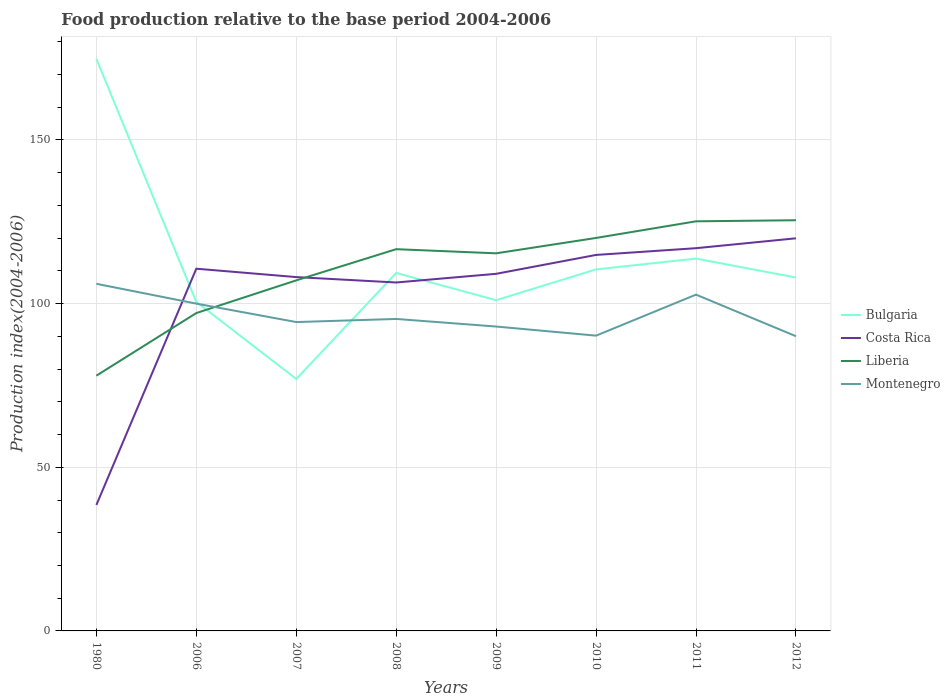Does the line corresponding to Montenegro intersect with the line corresponding to Liberia?
Make the answer very short. Yes. Is the number of lines equal to the number of legend labels?
Your answer should be very brief. Yes. Across all years, what is the maximum food production index in Costa Rica?
Offer a very short reply. 38.48. What is the total food production index in Costa Rica in the graph?
Offer a very short reply. -6.27. What is the difference between the highest and the second highest food production index in Montenegro?
Offer a very short reply. 16.02. How many lines are there?
Your answer should be compact. 4. How many years are there in the graph?
Your response must be concise. 8. How many legend labels are there?
Your response must be concise. 4. What is the title of the graph?
Your answer should be very brief. Food production relative to the base period 2004-2006. Does "Morocco" appear as one of the legend labels in the graph?
Give a very brief answer. No. What is the label or title of the Y-axis?
Provide a succinct answer. Production index(2004-2006). What is the Production index(2004-2006) in Bulgaria in 1980?
Make the answer very short. 174.78. What is the Production index(2004-2006) of Costa Rica in 1980?
Offer a very short reply. 38.48. What is the Production index(2004-2006) in Liberia in 1980?
Your answer should be very brief. 77.99. What is the Production index(2004-2006) of Montenegro in 1980?
Offer a terse response. 106.06. What is the Production index(2004-2006) of Bulgaria in 2006?
Your answer should be very brief. 100.53. What is the Production index(2004-2006) of Costa Rica in 2006?
Give a very brief answer. 110.67. What is the Production index(2004-2006) of Liberia in 2006?
Your response must be concise. 97.12. What is the Production index(2004-2006) of Bulgaria in 2007?
Provide a short and direct response. 76.98. What is the Production index(2004-2006) of Costa Rica in 2007?
Provide a succinct answer. 108.11. What is the Production index(2004-2006) in Liberia in 2007?
Provide a succinct answer. 107.11. What is the Production index(2004-2006) in Montenegro in 2007?
Offer a terse response. 94.37. What is the Production index(2004-2006) of Bulgaria in 2008?
Your response must be concise. 109.37. What is the Production index(2004-2006) in Costa Rica in 2008?
Make the answer very short. 106.46. What is the Production index(2004-2006) in Liberia in 2008?
Your answer should be compact. 116.64. What is the Production index(2004-2006) in Montenegro in 2008?
Provide a succinct answer. 95.32. What is the Production index(2004-2006) in Bulgaria in 2009?
Ensure brevity in your answer.  101.05. What is the Production index(2004-2006) in Costa Rica in 2009?
Make the answer very short. 109.11. What is the Production index(2004-2006) in Liberia in 2009?
Your answer should be very brief. 115.37. What is the Production index(2004-2006) in Montenegro in 2009?
Give a very brief answer. 93. What is the Production index(2004-2006) of Bulgaria in 2010?
Ensure brevity in your answer.  110.47. What is the Production index(2004-2006) in Costa Rica in 2010?
Make the answer very short. 114.88. What is the Production index(2004-2006) of Liberia in 2010?
Make the answer very short. 120.07. What is the Production index(2004-2006) in Montenegro in 2010?
Ensure brevity in your answer.  90.22. What is the Production index(2004-2006) in Bulgaria in 2011?
Ensure brevity in your answer.  113.76. What is the Production index(2004-2006) in Costa Rica in 2011?
Ensure brevity in your answer.  116.94. What is the Production index(2004-2006) of Liberia in 2011?
Your response must be concise. 125.15. What is the Production index(2004-2006) in Montenegro in 2011?
Keep it short and to the point. 102.75. What is the Production index(2004-2006) of Bulgaria in 2012?
Your answer should be compact. 107.98. What is the Production index(2004-2006) of Costa Rica in 2012?
Keep it short and to the point. 119.96. What is the Production index(2004-2006) of Liberia in 2012?
Your answer should be compact. 125.48. What is the Production index(2004-2006) in Montenegro in 2012?
Keep it short and to the point. 90.04. Across all years, what is the maximum Production index(2004-2006) of Bulgaria?
Give a very brief answer. 174.78. Across all years, what is the maximum Production index(2004-2006) of Costa Rica?
Ensure brevity in your answer.  119.96. Across all years, what is the maximum Production index(2004-2006) in Liberia?
Ensure brevity in your answer.  125.48. Across all years, what is the maximum Production index(2004-2006) in Montenegro?
Provide a succinct answer. 106.06. Across all years, what is the minimum Production index(2004-2006) of Bulgaria?
Provide a succinct answer. 76.98. Across all years, what is the minimum Production index(2004-2006) of Costa Rica?
Give a very brief answer. 38.48. Across all years, what is the minimum Production index(2004-2006) of Liberia?
Provide a short and direct response. 77.99. Across all years, what is the minimum Production index(2004-2006) in Montenegro?
Provide a short and direct response. 90.04. What is the total Production index(2004-2006) of Bulgaria in the graph?
Provide a short and direct response. 894.92. What is the total Production index(2004-2006) of Costa Rica in the graph?
Give a very brief answer. 824.61. What is the total Production index(2004-2006) of Liberia in the graph?
Your answer should be very brief. 884.93. What is the total Production index(2004-2006) of Montenegro in the graph?
Your response must be concise. 771.76. What is the difference between the Production index(2004-2006) in Bulgaria in 1980 and that in 2006?
Ensure brevity in your answer.  74.25. What is the difference between the Production index(2004-2006) of Costa Rica in 1980 and that in 2006?
Give a very brief answer. -72.19. What is the difference between the Production index(2004-2006) in Liberia in 1980 and that in 2006?
Your answer should be very brief. -19.13. What is the difference between the Production index(2004-2006) of Montenegro in 1980 and that in 2006?
Keep it short and to the point. 6.06. What is the difference between the Production index(2004-2006) of Bulgaria in 1980 and that in 2007?
Make the answer very short. 97.8. What is the difference between the Production index(2004-2006) of Costa Rica in 1980 and that in 2007?
Ensure brevity in your answer.  -69.63. What is the difference between the Production index(2004-2006) of Liberia in 1980 and that in 2007?
Ensure brevity in your answer.  -29.12. What is the difference between the Production index(2004-2006) of Montenegro in 1980 and that in 2007?
Your response must be concise. 11.69. What is the difference between the Production index(2004-2006) in Bulgaria in 1980 and that in 2008?
Make the answer very short. 65.41. What is the difference between the Production index(2004-2006) in Costa Rica in 1980 and that in 2008?
Your response must be concise. -67.98. What is the difference between the Production index(2004-2006) of Liberia in 1980 and that in 2008?
Your answer should be compact. -38.65. What is the difference between the Production index(2004-2006) in Montenegro in 1980 and that in 2008?
Offer a terse response. 10.74. What is the difference between the Production index(2004-2006) of Bulgaria in 1980 and that in 2009?
Your response must be concise. 73.73. What is the difference between the Production index(2004-2006) of Costa Rica in 1980 and that in 2009?
Offer a terse response. -70.63. What is the difference between the Production index(2004-2006) of Liberia in 1980 and that in 2009?
Your response must be concise. -37.38. What is the difference between the Production index(2004-2006) in Montenegro in 1980 and that in 2009?
Give a very brief answer. 13.06. What is the difference between the Production index(2004-2006) of Bulgaria in 1980 and that in 2010?
Make the answer very short. 64.31. What is the difference between the Production index(2004-2006) of Costa Rica in 1980 and that in 2010?
Your response must be concise. -76.4. What is the difference between the Production index(2004-2006) of Liberia in 1980 and that in 2010?
Your answer should be very brief. -42.08. What is the difference between the Production index(2004-2006) of Montenegro in 1980 and that in 2010?
Make the answer very short. 15.84. What is the difference between the Production index(2004-2006) in Bulgaria in 1980 and that in 2011?
Ensure brevity in your answer.  61.02. What is the difference between the Production index(2004-2006) of Costa Rica in 1980 and that in 2011?
Keep it short and to the point. -78.46. What is the difference between the Production index(2004-2006) of Liberia in 1980 and that in 2011?
Offer a very short reply. -47.16. What is the difference between the Production index(2004-2006) in Montenegro in 1980 and that in 2011?
Your answer should be compact. 3.31. What is the difference between the Production index(2004-2006) of Bulgaria in 1980 and that in 2012?
Provide a succinct answer. 66.8. What is the difference between the Production index(2004-2006) in Costa Rica in 1980 and that in 2012?
Give a very brief answer. -81.48. What is the difference between the Production index(2004-2006) of Liberia in 1980 and that in 2012?
Give a very brief answer. -47.49. What is the difference between the Production index(2004-2006) in Montenegro in 1980 and that in 2012?
Ensure brevity in your answer.  16.02. What is the difference between the Production index(2004-2006) in Bulgaria in 2006 and that in 2007?
Make the answer very short. 23.55. What is the difference between the Production index(2004-2006) of Costa Rica in 2006 and that in 2007?
Your answer should be compact. 2.56. What is the difference between the Production index(2004-2006) of Liberia in 2006 and that in 2007?
Your answer should be very brief. -9.99. What is the difference between the Production index(2004-2006) in Montenegro in 2006 and that in 2007?
Provide a succinct answer. 5.63. What is the difference between the Production index(2004-2006) of Bulgaria in 2006 and that in 2008?
Ensure brevity in your answer.  -8.84. What is the difference between the Production index(2004-2006) of Costa Rica in 2006 and that in 2008?
Provide a succinct answer. 4.21. What is the difference between the Production index(2004-2006) in Liberia in 2006 and that in 2008?
Provide a succinct answer. -19.52. What is the difference between the Production index(2004-2006) in Montenegro in 2006 and that in 2008?
Make the answer very short. 4.68. What is the difference between the Production index(2004-2006) in Bulgaria in 2006 and that in 2009?
Make the answer very short. -0.52. What is the difference between the Production index(2004-2006) in Costa Rica in 2006 and that in 2009?
Make the answer very short. 1.56. What is the difference between the Production index(2004-2006) in Liberia in 2006 and that in 2009?
Ensure brevity in your answer.  -18.25. What is the difference between the Production index(2004-2006) in Bulgaria in 2006 and that in 2010?
Your response must be concise. -9.94. What is the difference between the Production index(2004-2006) in Costa Rica in 2006 and that in 2010?
Your response must be concise. -4.21. What is the difference between the Production index(2004-2006) of Liberia in 2006 and that in 2010?
Your answer should be compact. -22.95. What is the difference between the Production index(2004-2006) in Montenegro in 2006 and that in 2010?
Your answer should be very brief. 9.78. What is the difference between the Production index(2004-2006) in Bulgaria in 2006 and that in 2011?
Offer a terse response. -13.23. What is the difference between the Production index(2004-2006) of Costa Rica in 2006 and that in 2011?
Provide a short and direct response. -6.27. What is the difference between the Production index(2004-2006) in Liberia in 2006 and that in 2011?
Offer a terse response. -28.03. What is the difference between the Production index(2004-2006) of Montenegro in 2006 and that in 2011?
Keep it short and to the point. -2.75. What is the difference between the Production index(2004-2006) of Bulgaria in 2006 and that in 2012?
Your answer should be very brief. -7.45. What is the difference between the Production index(2004-2006) in Costa Rica in 2006 and that in 2012?
Your response must be concise. -9.29. What is the difference between the Production index(2004-2006) in Liberia in 2006 and that in 2012?
Provide a succinct answer. -28.36. What is the difference between the Production index(2004-2006) in Montenegro in 2006 and that in 2012?
Ensure brevity in your answer.  9.96. What is the difference between the Production index(2004-2006) in Bulgaria in 2007 and that in 2008?
Your answer should be very brief. -32.39. What is the difference between the Production index(2004-2006) of Costa Rica in 2007 and that in 2008?
Ensure brevity in your answer.  1.65. What is the difference between the Production index(2004-2006) in Liberia in 2007 and that in 2008?
Offer a very short reply. -9.53. What is the difference between the Production index(2004-2006) in Montenegro in 2007 and that in 2008?
Give a very brief answer. -0.95. What is the difference between the Production index(2004-2006) of Bulgaria in 2007 and that in 2009?
Provide a short and direct response. -24.07. What is the difference between the Production index(2004-2006) of Liberia in 2007 and that in 2009?
Offer a terse response. -8.26. What is the difference between the Production index(2004-2006) of Montenegro in 2007 and that in 2009?
Keep it short and to the point. 1.37. What is the difference between the Production index(2004-2006) of Bulgaria in 2007 and that in 2010?
Keep it short and to the point. -33.49. What is the difference between the Production index(2004-2006) of Costa Rica in 2007 and that in 2010?
Offer a terse response. -6.77. What is the difference between the Production index(2004-2006) in Liberia in 2007 and that in 2010?
Ensure brevity in your answer.  -12.96. What is the difference between the Production index(2004-2006) in Montenegro in 2007 and that in 2010?
Your response must be concise. 4.15. What is the difference between the Production index(2004-2006) in Bulgaria in 2007 and that in 2011?
Offer a terse response. -36.78. What is the difference between the Production index(2004-2006) in Costa Rica in 2007 and that in 2011?
Offer a very short reply. -8.83. What is the difference between the Production index(2004-2006) in Liberia in 2007 and that in 2011?
Keep it short and to the point. -18.04. What is the difference between the Production index(2004-2006) of Montenegro in 2007 and that in 2011?
Ensure brevity in your answer.  -8.38. What is the difference between the Production index(2004-2006) in Bulgaria in 2007 and that in 2012?
Provide a short and direct response. -31. What is the difference between the Production index(2004-2006) of Costa Rica in 2007 and that in 2012?
Make the answer very short. -11.85. What is the difference between the Production index(2004-2006) of Liberia in 2007 and that in 2012?
Keep it short and to the point. -18.37. What is the difference between the Production index(2004-2006) of Montenegro in 2007 and that in 2012?
Keep it short and to the point. 4.33. What is the difference between the Production index(2004-2006) in Bulgaria in 2008 and that in 2009?
Provide a short and direct response. 8.32. What is the difference between the Production index(2004-2006) in Costa Rica in 2008 and that in 2009?
Provide a short and direct response. -2.65. What is the difference between the Production index(2004-2006) of Liberia in 2008 and that in 2009?
Your answer should be very brief. 1.27. What is the difference between the Production index(2004-2006) of Montenegro in 2008 and that in 2009?
Your answer should be very brief. 2.32. What is the difference between the Production index(2004-2006) in Bulgaria in 2008 and that in 2010?
Give a very brief answer. -1.1. What is the difference between the Production index(2004-2006) of Costa Rica in 2008 and that in 2010?
Give a very brief answer. -8.42. What is the difference between the Production index(2004-2006) of Liberia in 2008 and that in 2010?
Your response must be concise. -3.43. What is the difference between the Production index(2004-2006) of Montenegro in 2008 and that in 2010?
Your answer should be compact. 5.1. What is the difference between the Production index(2004-2006) of Bulgaria in 2008 and that in 2011?
Provide a succinct answer. -4.39. What is the difference between the Production index(2004-2006) in Costa Rica in 2008 and that in 2011?
Your response must be concise. -10.48. What is the difference between the Production index(2004-2006) in Liberia in 2008 and that in 2011?
Make the answer very short. -8.51. What is the difference between the Production index(2004-2006) in Montenegro in 2008 and that in 2011?
Keep it short and to the point. -7.43. What is the difference between the Production index(2004-2006) in Bulgaria in 2008 and that in 2012?
Your answer should be compact. 1.39. What is the difference between the Production index(2004-2006) in Costa Rica in 2008 and that in 2012?
Provide a succinct answer. -13.5. What is the difference between the Production index(2004-2006) of Liberia in 2008 and that in 2012?
Provide a succinct answer. -8.84. What is the difference between the Production index(2004-2006) of Montenegro in 2008 and that in 2012?
Give a very brief answer. 5.28. What is the difference between the Production index(2004-2006) of Bulgaria in 2009 and that in 2010?
Your answer should be very brief. -9.42. What is the difference between the Production index(2004-2006) of Costa Rica in 2009 and that in 2010?
Offer a very short reply. -5.77. What is the difference between the Production index(2004-2006) of Montenegro in 2009 and that in 2010?
Your answer should be very brief. 2.78. What is the difference between the Production index(2004-2006) in Bulgaria in 2009 and that in 2011?
Your response must be concise. -12.71. What is the difference between the Production index(2004-2006) in Costa Rica in 2009 and that in 2011?
Give a very brief answer. -7.83. What is the difference between the Production index(2004-2006) in Liberia in 2009 and that in 2011?
Offer a terse response. -9.78. What is the difference between the Production index(2004-2006) in Montenegro in 2009 and that in 2011?
Provide a succinct answer. -9.75. What is the difference between the Production index(2004-2006) of Bulgaria in 2009 and that in 2012?
Keep it short and to the point. -6.93. What is the difference between the Production index(2004-2006) of Costa Rica in 2009 and that in 2012?
Your answer should be very brief. -10.85. What is the difference between the Production index(2004-2006) in Liberia in 2009 and that in 2012?
Your response must be concise. -10.11. What is the difference between the Production index(2004-2006) of Montenegro in 2009 and that in 2012?
Your answer should be compact. 2.96. What is the difference between the Production index(2004-2006) of Bulgaria in 2010 and that in 2011?
Offer a terse response. -3.29. What is the difference between the Production index(2004-2006) of Costa Rica in 2010 and that in 2011?
Provide a succinct answer. -2.06. What is the difference between the Production index(2004-2006) of Liberia in 2010 and that in 2011?
Give a very brief answer. -5.08. What is the difference between the Production index(2004-2006) in Montenegro in 2010 and that in 2011?
Your response must be concise. -12.53. What is the difference between the Production index(2004-2006) in Bulgaria in 2010 and that in 2012?
Offer a very short reply. 2.49. What is the difference between the Production index(2004-2006) in Costa Rica in 2010 and that in 2012?
Keep it short and to the point. -5.08. What is the difference between the Production index(2004-2006) in Liberia in 2010 and that in 2012?
Ensure brevity in your answer.  -5.41. What is the difference between the Production index(2004-2006) of Montenegro in 2010 and that in 2012?
Offer a very short reply. 0.18. What is the difference between the Production index(2004-2006) in Bulgaria in 2011 and that in 2012?
Offer a very short reply. 5.78. What is the difference between the Production index(2004-2006) of Costa Rica in 2011 and that in 2012?
Offer a very short reply. -3.02. What is the difference between the Production index(2004-2006) of Liberia in 2011 and that in 2012?
Keep it short and to the point. -0.33. What is the difference between the Production index(2004-2006) in Montenegro in 2011 and that in 2012?
Ensure brevity in your answer.  12.71. What is the difference between the Production index(2004-2006) of Bulgaria in 1980 and the Production index(2004-2006) of Costa Rica in 2006?
Your answer should be very brief. 64.11. What is the difference between the Production index(2004-2006) of Bulgaria in 1980 and the Production index(2004-2006) of Liberia in 2006?
Offer a terse response. 77.66. What is the difference between the Production index(2004-2006) in Bulgaria in 1980 and the Production index(2004-2006) in Montenegro in 2006?
Make the answer very short. 74.78. What is the difference between the Production index(2004-2006) of Costa Rica in 1980 and the Production index(2004-2006) of Liberia in 2006?
Make the answer very short. -58.64. What is the difference between the Production index(2004-2006) in Costa Rica in 1980 and the Production index(2004-2006) in Montenegro in 2006?
Ensure brevity in your answer.  -61.52. What is the difference between the Production index(2004-2006) in Liberia in 1980 and the Production index(2004-2006) in Montenegro in 2006?
Keep it short and to the point. -22.01. What is the difference between the Production index(2004-2006) of Bulgaria in 1980 and the Production index(2004-2006) of Costa Rica in 2007?
Your answer should be compact. 66.67. What is the difference between the Production index(2004-2006) in Bulgaria in 1980 and the Production index(2004-2006) in Liberia in 2007?
Provide a short and direct response. 67.67. What is the difference between the Production index(2004-2006) in Bulgaria in 1980 and the Production index(2004-2006) in Montenegro in 2007?
Provide a short and direct response. 80.41. What is the difference between the Production index(2004-2006) in Costa Rica in 1980 and the Production index(2004-2006) in Liberia in 2007?
Your answer should be compact. -68.63. What is the difference between the Production index(2004-2006) of Costa Rica in 1980 and the Production index(2004-2006) of Montenegro in 2007?
Offer a terse response. -55.89. What is the difference between the Production index(2004-2006) of Liberia in 1980 and the Production index(2004-2006) of Montenegro in 2007?
Give a very brief answer. -16.38. What is the difference between the Production index(2004-2006) in Bulgaria in 1980 and the Production index(2004-2006) in Costa Rica in 2008?
Your answer should be very brief. 68.32. What is the difference between the Production index(2004-2006) of Bulgaria in 1980 and the Production index(2004-2006) of Liberia in 2008?
Your answer should be very brief. 58.14. What is the difference between the Production index(2004-2006) in Bulgaria in 1980 and the Production index(2004-2006) in Montenegro in 2008?
Provide a succinct answer. 79.46. What is the difference between the Production index(2004-2006) of Costa Rica in 1980 and the Production index(2004-2006) of Liberia in 2008?
Provide a succinct answer. -78.16. What is the difference between the Production index(2004-2006) of Costa Rica in 1980 and the Production index(2004-2006) of Montenegro in 2008?
Your answer should be compact. -56.84. What is the difference between the Production index(2004-2006) of Liberia in 1980 and the Production index(2004-2006) of Montenegro in 2008?
Keep it short and to the point. -17.33. What is the difference between the Production index(2004-2006) in Bulgaria in 1980 and the Production index(2004-2006) in Costa Rica in 2009?
Offer a very short reply. 65.67. What is the difference between the Production index(2004-2006) of Bulgaria in 1980 and the Production index(2004-2006) of Liberia in 2009?
Your response must be concise. 59.41. What is the difference between the Production index(2004-2006) of Bulgaria in 1980 and the Production index(2004-2006) of Montenegro in 2009?
Ensure brevity in your answer.  81.78. What is the difference between the Production index(2004-2006) in Costa Rica in 1980 and the Production index(2004-2006) in Liberia in 2009?
Your answer should be very brief. -76.89. What is the difference between the Production index(2004-2006) in Costa Rica in 1980 and the Production index(2004-2006) in Montenegro in 2009?
Provide a succinct answer. -54.52. What is the difference between the Production index(2004-2006) of Liberia in 1980 and the Production index(2004-2006) of Montenegro in 2009?
Offer a terse response. -15.01. What is the difference between the Production index(2004-2006) of Bulgaria in 1980 and the Production index(2004-2006) of Costa Rica in 2010?
Provide a short and direct response. 59.9. What is the difference between the Production index(2004-2006) of Bulgaria in 1980 and the Production index(2004-2006) of Liberia in 2010?
Offer a very short reply. 54.71. What is the difference between the Production index(2004-2006) of Bulgaria in 1980 and the Production index(2004-2006) of Montenegro in 2010?
Give a very brief answer. 84.56. What is the difference between the Production index(2004-2006) in Costa Rica in 1980 and the Production index(2004-2006) in Liberia in 2010?
Provide a succinct answer. -81.59. What is the difference between the Production index(2004-2006) in Costa Rica in 1980 and the Production index(2004-2006) in Montenegro in 2010?
Your response must be concise. -51.74. What is the difference between the Production index(2004-2006) of Liberia in 1980 and the Production index(2004-2006) of Montenegro in 2010?
Your answer should be very brief. -12.23. What is the difference between the Production index(2004-2006) of Bulgaria in 1980 and the Production index(2004-2006) of Costa Rica in 2011?
Offer a terse response. 57.84. What is the difference between the Production index(2004-2006) of Bulgaria in 1980 and the Production index(2004-2006) of Liberia in 2011?
Offer a very short reply. 49.63. What is the difference between the Production index(2004-2006) of Bulgaria in 1980 and the Production index(2004-2006) of Montenegro in 2011?
Your answer should be very brief. 72.03. What is the difference between the Production index(2004-2006) in Costa Rica in 1980 and the Production index(2004-2006) in Liberia in 2011?
Your response must be concise. -86.67. What is the difference between the Production index(2004-2006) of Costa Rica in 1980 and the Production index(2004-2006) of Montenegro in 2011?
Give a very brief answer. -64.27. What is the difference between the Production index(2004-2006) of Liberia in 1980 and the Production index(2004-2006) of Montenegro in 2011?
Your answer should be very brief. -24.76. What is the difference between the Production index(2004-2006) of Bulgaria in 1980 and the Production index(2004-2006) of Costa Rica in 2012?
Keep it short and to the point. 54.82. What is the difference between the Production index(2004-2006) in Bulgaria in 1980 and the Production index(2004-2006) in Liberia in 2012?
Your answer should be compact. 49.3. What is the difference between the Production index(2004-2006) of Bulgaria in 1980 and the Production index(2004-2006) of Montenegro in 2012?
Offer a terse response. 84.74. What is the difference between the Production index(2004-2006) in Costa Rica in 1980 and the Production index(2004-2006) in Liberia in 2012?
Your answer should be compact. -87. What is the difference between the Production index(2004-2006) in Costa Rica in 1980 and the Production index(2004-2006) in Montenegro in 2012?
Keep it short and to the point. -51.56. What is the difference between the Production index(2004-2006) in Liberia in 1980 and the Production index(2004-2006) in Montenegro in 2012?
Ensure brevity in your answer.  -12.05. What is the difference between the Production index(2004-2006) in Bulgaria in 2006 and the Production index(2004-2006) in Costa Rica in 2007?
Provide a succinct answer. -7.58. What is the difference between the Production index(2004-2006) in Bulgaria in 2006 and the Production index(2004-2006) in Liberia in 2007?
Offer a very short reply. -6.58. What is the difference between the Production index(2004-2006) in Bulgaria in 2006 and the Production index(2004-2006) in Montenegro in 2007?
Offer a very short reply. 6.16. What is the difference between the Production index(2004-2006) of Costa Rica in 2006 and the Production index(2004-2006) of Liberia in 2007?
Provide a short and direct response. 3.56. What is the difference between the Production index(2004-2006) of Liberia in 2006 and the Production index(2004-2006) of Montenegro in 2007?
Your response must be concise. 2.75. What is the difference between the Production index(2004-2006) in Bulgaria in 2006 and the Production index(2004-2006) in Costa Rica in 2008?
Keep it short and to the point. -5.93. What is the difference between the Production index(2004-2006) in Bulgaria in 2006 and the Production index(2004-2006) in Liberia in 2008?
Offer a very short reply. -16.11. What is the difference between the Production index(2004-2006) of Bulgaria in 2006 and the Production index(2004-2006) of Montenegro in 2008?
Offer a terse response. 5.21. What is the difference between the Production index(2004-2006) in Costa Rica in 2006 and the Production index(2004-2006) in Liberia in 2008?
Your answer should be very brief. -5.97. What is the difference between the Production index(2004-2006) in Costa Rica in 2006 and the Production index(2004-2006) in Montenegro in 2008?
Keep it short and to the point. 15.35. What is the difference between the Production index(2004-2006) in Bulgaria in 2006 and the Production index(2004-2006) in Costa Rica in 2009?
Provide a short and direct response. -8.58. What is the difference between the Production index(2004-2006) in Bulgaria in 2006 and the Production index(2004-2006) in Liberia in 2009?
Your answer should be compact. -14.84. What is the difference between the Production index(2004-2006) in Bulgaria in 2006 and the Production index(2004-2006) in Montenegro in 2009?
Keep it short and to the point. 7.53. What is the difference between the Production index(2004-2006) in Costa Rica in 2006 and the Production index(2004-2006) in Montenegro in 2009?
Provide a short and direct response. 17.67. What is the difference between the Production index(2004-2006) of Liberia in 2006 and the Production index(2004-2006) of Montenegro in 2009?
Ensure brevity in your answer.  4.12. What is the difference between the Production index(2004-2006) of Bulgaria in 2006 and the Production index(2004-2006) of Costa Rica in 2010?
Your response must be concise. -14.35. What is the difference between the Production index(2004-2006) in Bulgaria in 2006 and the Production index(2004-2006) in Liberia in 2010?
Your response must be concise. -19.54. What is the difference between the Production index(2004-2006) of Bulgaria in 2006 and the Production index(2004-2006) of Montenegro in 2010?
Ensure brevity in your answer.  10.31. What is the difference between the Production index(2004-2006) in Costa Rica in 2006 and the Production index(2004-2006) in Liberia in 2010?
Provide a succinct answer. -9.4. What is the difference between the Production index(2004-2006) in Costa Rica in 2006 and the Production index(2004-2006) in Montenegro in 2010?
Give a very brief answer. 20.45. What is the difference between the Production index(2004-2006) of Bulgaria in 2006 and the Production index(2004-2006) of Costa Rica in 2011?
Ensure brevity in your answer.  -16.41. What is the difference between the Production index(2004-2006) in Bulgaria in 2006 and the Production index(2004-2006) in Liberia in 2011?
Keep it short and to the point. -24.62. What is the difference between the Production index(2004-2006) in Bulgaria in 2006 and the Production index(2004-2006) in Montenegro in 2011?
Offer a very short reply. -2.22. What is the difference between the Production index(2004-2006) in Costa Rica in 2006 and the Production index(2004-2006) in Liberia in 2011?
Provide a short and direct response. -14.48. What is the difference between the Production index(2004-2006) of Costa Rica in 2006 and the Production index(2004-2006) of Montenegro in 2011?
Your response must be concise. 7.92. What is the difference between the Production index(2004-2006) in Liberia in 2006 and the Production index(2004-2006) in Montenegro in 2011?
Make the answer very short. -5.63. What is the difference between the Production index(2004-2006) in Bulgaria in 2006 and the Production index(2004-2006) in Costa Rica in 2012?
Your answer should be very brief. -19.43. What is the difference between the Production index(2004-2006) in Bulgaria in 2006 and the Production index(2004-2006) in Liberia in 2012?
Give a very brief answer. -24.95. What is the difference between the Production index(2004-2006) of Bulgaria in 2006 and the Production index(2004-2006) of Montenegro in 2012?
Keep it short and to the point. 10.49. What is the difference between the Production index(2004-2006) in Costa Rica in 2006 and the Production index(2004-2006) in Liberia in 2012?
Provide a succinct answer. -14.81. What is the difference between the Production index(2004-2006) of Costa Rica in 2006 and the Production index(2004-2006) of Montenegro in 2012?
Provide a succinct answer. 20.63. What is the difference between the Production index(2004-2006) of Liberia in 2006 and the Production index(2004-2006) of Montenegro in 2012?
Your answer should be very brief. 7.08. What is the difference between the Production index(2004-2006) in Bulgaria in 2007 and the Production index(2004-2006) in Costa Rica in 2008?
Offer a terse response. -29.48. What is the difference between the Production index(2004-2006) of Bulgaria in 2007 and the Production index(2004-2006) of Liberia in 2008?
Provide a short and direct response. -39.66. What is the difference between the Production index(2004-2006) in Bulgaria in 2007 and the Production index(2004-2006) in Montenegro in 2008?
Your answer should be compact. -18.34. What is the difference between the Production index(2004-2006) of Costa Rica in 2007 and the Production index(2004-2006) of Liberia in 2008?
Your response must be concise. -8.53. What is the difference between the Production index(2004-2006) of Costa Rica in 2007 and the Production index(2004-2006) of Montenegro in 2008?
Your answer should be compact. 12.79. What is the difference between the Production index(2004-2006) in Liberia in 2007 and the Production index(2004-2006) in Montenegro in 2008?
Provide a short and direct response. 11.79. What is the difference between the Production index(2004-2006) of Bulgaria in 2007 and the Production index(2004-2006) of Costa Rica in 2009?
Keep it short and to the point. -32.13. What is the difference between the Production index(2004-2006) in Bulgaria in 2007 and the Production index(2004-2006) in Liberia in 2009?
Make the answer very short. -38.39. What is the difference between the Production index(2004-2006) of Bulgaria in 2007 and the Production index(2004-2006) of Montenegro in 2009?
Keep it short and to the point. -16.02. What is the difference between the Production index(2004-2006) in Costa Rica in 2007 and the Production index(2004-2006) in Liberia in 2009?
Your response must be concise. -7.26. What is the difference between the Production index(2004-2006) in Costa Rica in 2007 and the Production index(2004-2006) in Montenegro in 2009?
Your answer should be very brief. 15.11. What is the difference between the Production index(2004-2006) in Liberia in 2007 and the Production index(2004-2006) in Montenegro in 2009?
Your response must be concise. 14.11. What is the difference between the Production index(2004-2006) in Bulgaria in 2007 and the Production index(2004-2006) in Costa Rica in 2010?
Keep it short and to the point. -37.9. What is the difference between the Production index(2004-2006) of Bulgaria in 2007 and the Production index(2004-2006) of Liberia in 2010?
Your answer should be compact. -43.09. What is the difference between the Production index(2004-2006) in Bulgaria in 2007 and the Production index(2004-2006) in Montenegro in 2010?
Your answer should be very brief. -13.24. What is the difference between the Production index(2004-2006) in Costa Rica in 2007 and the Production index(2004-2006) in Liberia in 2010?
Give a very brief answer. -11.96. What is the difference between the Production index(2004-2006) in Costa Rica in 2007 and the Production index(2004-2006) in Montenegro in 2010?
Offer a very short reply. 17.89. What is the difference between the Production index(2004-2006) in Liberia in 2007 and the Production index(2004-2006) in Montenegro in 2010?
Your response must be concise. 16.89. What is the difference between the Production index(2004-2006) of Bulgaria in 2007 and the Production index(2004-2006) of Costa Rica in 2011?
Give a very brief answer. -39.96. What is the difference between the Production index(2004-2006) in Bulgaria in 2007 and the Production index(2004-2006) in Liberia in 2011?
Your answer should be compact. -48.17. What is the difference between the Production index(2004-2006) in Bulgaria in 2007 and the Production index(2004-2006) in Montenegro in 2011?
Offer a terse response. -25.77. What is the difference between the Production index(2004-2006) in Costa Rica in 2007 and the Production index(2004-2006) in Liberia in 2011?
Your answer should be compact. -17.04. What is the difference between the Production index(2004-2006) of Costa Rica in 2007 and the Production index(2004-2006) of Montenegro in 2011?
Make the answer very short. 5.36. What is the difference between the Production index(2004-2006) of Liberia in 2007 and the Production index(2004-2006) of Montenegro in 2011?
Your response must be concise. 4.36. What is the difference between the Production index(2004-2006) of Bulgaria in 2007 and the Production index(2004-2006) of Costa Rica in 2012?
Provide a short and direct response. -42.98. What is the difference between the Production index(2004-2006) of Bulgaria in 2007 and the Production index(2004-2006) of Liberia in 2012?
Provide a short and direct response. -48.5. What is the difference between the Production index(2004-2006) of Bulgaria in 2007 and the Production index(2004-2006) of Montenegro in 2012?
Make the answer very short. -13.06. What is the difference between the Production index(2004-2006) in Costa Rica in 2007 and the Production index(2004-2006) in Liberia in 2012?
Offer a terse response. -17.37. What is the difference between the Production index(2004-2006) in Costa Rica in 2007 and the Production index(2004-2006) in Montenegro in 2012?
Your response must be concise. 18.07. What is the difference between the Production index(2004-2006) in Liberia in 2007 and the Production index(2004-2006) in Montenegro in 2012?
Your answer should be compact. 17.07. What is the difference between the Production index(2004-2006) of Bulgaria in 2008 and the Production index(2004-2006) of Costa Rica in 2009?
Keep it short and to the point. 0.26. What is the difference between the Production index(2004-2006) in Bulgaria in 2008 and the Production index(2004-2006) in Montenegro in 2009?
Keep it short and to the point. 16.37. What is the difference between the Production index(2004-2006) of Costa Rica in 2008 and the Production index(2004-2006) of Liberia in 2009?
Keep it short and to the point. -8.91. What is the difference between the Production index(2004-2006) of Costa Rica in 2008 and the Production index(2004-2006) of Montenegro in 2009?
Your response must be concise. 13.46. What is the difference between the Production index(2004-2006) of Liberia in 2008 and the Production index(2004-2006) of Montenegro in 2009?
Your answer should be compact. 23.64. What is the difference between the Production index(2004-2006) in Bulgaria in 2008 and the Production index(2004-2006) in Costa Rica in 2010?
Your answer should be compact. -5.51. What is the difference between the Production index(2004-2006) in Bulgaria in 2008 and the Production index(2004-2006) in Montenegro in 2010?
Give a very brief answer. 19.15. What is the difference between the Production index(2004-2006) of Costa Rica in 2008 and the Production index(2004-2006) of Liberia in 2010?
Keep it short and to the point. -13.61. What is the difference between the Production index(2004-2006) in Costa Rica in 2008 and the Production index(2004-2006) in Montenegro in 2010?
Offer a very short reply. 16.24. What is the difference between the Production index(2004-2006) in Liberia in 2008 and the Production index(2004-2006) in Montenegro in 2010?
Make the answer very short. 26.42. What is the difference between the Production index(2004-2006) of Bulgaria in 2008 and the Production index(2004-2006) of Costa Rica in 2011?
Ensure brevity in your answer.  -7.57. What is the difference between the Production index(2004-2006) in Bulgaria in 2008 and the Production index(2004-2006) in Liberia in 2011?
Provide a short and direct response. -15.78. What is the difference between the Production index(2004-2006) in Bulgaria in 2008 and the Production index(2004-2006) in Montenegro in 2011?
Offer a terse response. 6.62. What is the difference between the Production index(2004-2006) of Costa Rica in 2008 and the Production index(2004-2006) of Liberia in 2011?
Your answer should be very brief. -18.69. What is the difference between the Production index(2004-2006) of Costa Rica in 2008 and the Production index(2004-2006) of Montenegro in 2011?
Offer a terse response. 3.71. What is the difference between the Production index(2004-2006) in Liberia in 2008 and the Production index(2004-2006) in Montenegro in 2011?
Provide a succinct answer. 13.89. What is the difference between the Production index(2004-2006) in Bulgaria in 2008 and the Production index(2004-2006) in Costa Rica in 2012?
Offer a terse response. -10.59. What is the difference between the Production index(2004-2006) of Bulgaria in 2008 and the Production index(2004-2006) of Liberia in 2012?
Ensure brevity in your answer.  -16.11. What is the difference between the Production index(2004-2006) in Bulgaria in 2008 and the Production index(2004-2006) in Montenegro in 2012?
Offer a very short reply. 19.33. What is the difference between the Production index(2004-2006) of Costa Rica in 2008 and the Production index(2004-2006) of Liberia in 2012?
Your answer should be very brief. -19.02. What is the difference between the Production index(2004-2006) of Costa Rica in 2008 and the Production index(2004-2006) of Montenegro in 2012?
Make the answer very short. 16.42. What is the difference between the Production index(2004-2006) in Liberia in 2008 and the Production index(2004-2006) in Montenegro in 2012?
Your answer should be very brief. 26.6. What is the difference between the Production index(2004-2006) of Bulgaria in 2009 and the Production index(2004-2006) of Costa Rica in 2010?
Offer a very short reply. -13.83. What is the difference between the Production index(2004-2006) in Bulgaria in 2009 and the Production index(2004-2006) in Liberia in 2010?
Make the answer very short. -19.02. What is the difference between the Production index(2004-2006) in Bulgaria in 2009 and the Production index(2004-2006) in Montenegro in 2010?
Give a very brief answer. 10.83. What is the difference between the Production index(2004-2006) of Costa Rica in 2009 and the Production index(2004-2006) of Liberia in 2010?
Offer a terse response. -10.96. What is the difference between the Production index(2004-2006) in Costa Rica in 2009 and the Production index(2004-2006) in Montenegro in 2010?
Offer a very short reply. 18.89. What is the difference between the Production index(2004-2006) of Liberia in 2009 and the Production index(2004-2006) of Montenegro in 2010?
Provide a succinct answer. 25.15. What is the difference between the Production index(2004-2006) of Bulgaria in 2009 and the Production index(2004-2006) of Costa Rica in 2011?
Ensure brevity in your answer.  -15.89. What is the difference between the Production index(2004-2006) of Bulgaria in 2009 and the Production index(2004-2006) of Liberia in 2011?
Offer a very short reply. -24.1. What is the difference between the Production index(2004-2006) in Bulgaria in 2009 and the Production index(2004-2006) in Montenegro in 2011?
Your answer should be very brief. -1.7. What is the difference between the Production index(2004-2006) in Costa Rica in 2009 and the Production index(2004-2006) in Liberia in 2011?
Offer a terse response. -16.04. What is the difference between the Production index(2004-2006) of Costa Rica in 2009 and the Production index(2004-2006) of Montenegro in 2011?
Make the answer very short. 6.36. What is the difference between the Production index(2004-2006) in Liberia in 2009 and the Production index(2004-2006) in Montenegro in 2011?
Provide a short and direct response. 12.62. What is the difference between the Production index(2004-2006) in Bulgaria in 2009 and the Production index(2004-2006) in Costa Rica in 2012?
Provide a short and direct response. -18.91. What is the difference between the Production index(2004-2006) of Bulgaria in 2009 and the Production index(2004-2006) of Liberia in 2012?
Provide a succinct answer. -24.43. What is the difference between the Production index(2004-2006) of Bulgaria in 2009 and the Production index(2004-2006) of Montenegro in 2012?
Keep it short and to the point. 11.01. What is the difference between the Production index(2004-2006) in Costa Rica in 2009 and the Production index(2004-2006) in Liberia in 2012?
Offer a terse response. -16.37. What is the difference between the Production index(2004-2006) of Costa Rica in 2009 and the Production index(2004-2006) of Montenegro in 2012?
Your answer should be very brief. 19.07. What is the difference between the Production index(2004-2006) of Liberia in 2009 and the Production index(2004-2006) of Montenegro in 2012?
Your answer should be very brief. 25.33. What is the difference between the Production index(2004-2006) in Bulgaria in 2010 and the Production index(2004-2006) in Costa Rica in 2011?
Provide a short and direct response. -6.47. What is the difference between the Production index(2004-2006) in Bulgaria in 2010 and the Production index(2004-2006) in Liberia in 2011?
Offer a very short reply. -14.68. What is the difference between the Production index(2004-2006) in Bulgaria in 2010 and the Production index(2004-2006) in Montenegro in 2011?
Offer a very short reply. 7.72. What is the difference between the Production index(2004-2006) of Costa Rica in 2010 and the Production index(2004-2006) of Liberia in 2011?
Provide a succinct answer. -10.27. What is the difference between the Production index(2004-2006) of Costa Rica in 2010 and the Production index(2004-2006) of Montenegro in 2011?
Your answer should be compact. 12.13. What is the difference between the Production index(2004-2006) in Liberia in 2010 and the Production index(2004-2006) in Montenegro in 2011?
Keep it short and to the point. 17.32. What is the difference between the Production index(2004-2006) in Bulgaria in 2010 and the Production index(2004-2006) in Costa Rica in 2012?
Your response must be concise. -9.49. What is the difference between the Production index(2004-2006) of Bulgaria in 2010 and the Production index(2004-2006) of Liberia in 2012?
Offer a terse response. -15.01. What is the difference between the Production index(2004-2006) of Bulgaria in 2010 and the Production index(2004-2006) of Montenegro in 2012?
Offer a very short reply. 20.43. What is the difference between the Production index(2004-2006) in Costa Rica in 2010 and the Production index(2004-2006) in Montenegro in 2012?
Ensure brevity in your answer.  24.84. What is the difference between the Production index(2004-2006) in Liberia in 2010 and the Production index(2004-2006) in Montenegro in 2012?
Ensure brevity in your answer.  30.03. What is the difference between the Production index(2004-2006) of Bulgaria in 2011 and the Production index(2004-2006) of Costa Rica in 2012?
Offer a terse response. -6.2. What is the difference between the Production index(2004-2006) in Bulgaria in 2011 and the Production index(2004-2006) in Liberia in 2012?
Provide a short and direct response. -11.72. What is the difference between the Production index(2004-2006) in Bulgaria in 2011 and the Production index(2004-2006) in Montenegro in 2012?
Your answer should be compact. 23.72. What is the difference between the Production index(2004-2006) in Costa Rica in 2011 and the Production index(2004-2006) in Liberia in 2012?
Offer a terse response. -8.54. What is the difference between the Production index(2004-2006) of Costa Rica in 2011 and the Production index(2004-2006) of Montenegro in 2012?
Provide a short and direct response. 26.9. What is the difference between the Production index(2004-2006) in Liberia in 2011 and the Production index(2004-2006) in Montenegro in 2012?
Offer a very short reply. 35.11. What is the average Production index(2004-2006) of Bulgaria per year?
Make the answer very short. 111.86. What is the average Production index(2004-2006) in Costa Rica per year?
Offer a terse response. 103.08. What is the average Production index(2004-2006) in Liberia per year?
Your answer should be compact. 110.62. What is the average Production index(2004-2006) in Montenegro per year?
Your response must be concise. 96.47. In the year 1980, what is the difference between the Production index(2004-2006) in Bulgaria and Production index(2004-2006) in Costa Rica?
Give a very brief answer. 136.3. In the year 1980, what is the difference between the Production index(2004-2006) in Bulgaria and Production index(2004-2006) in Liberia?
Provide a succinct answer. 96.79. In the year 1980, what is the difference between the Production index(2004-2006) of Bulgaria and Production index(2004-2006) of Montenegro?
Provide a succinct answer. 68.72. In the year 1980, what is the difference between the Production index(2004-2006) of Costa Rica and Production index(2004-2006) of Liberia?
Provide a short and direct response. -39.51. In the year 1980, what is the difference between the Production index(2004-2006) in Costa Rica and Production index(2004-2006) in Montenegro?
Provide a succinct answer. -67.58. In the year 1980, what is the difference between the Production index(2004-2006) of Liberia and Production index(2004-2006) of Montenegro?
Make the answer very short. -28.07. In the year 2006, what is the difference between the Production index(2004-2006) of Bulgaria and Production index(2004-2006) of Costa Rica?
Ensure brevity in your answer.  -10.14. In the year 2006, what is the difference between the Production index(2004-2006) of Bulgaria and Production index(2004-2006) of Liberia?
Keep it short and to the point. 3.41. In the year 2006, what is the difference between the Production index(2004-2006) in Bulgaria and Production index(2004-2006) in Montenegro?
Your answer should be compact. 0.53. In the year 2006, what is the difference between the Production index(2004-2006) in Costa Rica and Production index(2004-2006) in Liberia?
Ensure brevity in your answer.  13.55. In the year 2006, what is the difference between the Production index(2004-2006) in Costa Rica and Production index(2004-2006) in Montenegro?
Provide a short and direct response. 10.67. In the year 2006, what is the difference between the Production index(2004-2006) in Liberia and Production index(2004-2006) in Montenegro?
Your answer should be very brief. -2.88. In the year 2007, what is the difference between the Production index(2004-2006) of Bulgaria and Production index(2004-2006) of Costa Rica?
Give a very brief answer. -31.13. In the year 2007, what is the difference between the Production index(2004-2006) of Bulgaria and Production index(2004-2006) of Liberia?
Your response must be concise. -30.13. In the year 2007, what is the difference between the Production index(2004-2006) of Bulgaria and Production index(2004-2006) of Montenegro?
Offer a terse response. -17.39. In the year 2007, what is the difference between the Production index(2004-2006) of Costa Rica and Production index(2004-2006) of Liberia?
Make the answer very short. 1. In the year 2007, what is the difference between the Production index(2004-2006) of Costa Rica and Production index(2004-2006) of Montenegro?
Your answer should be very brief. 13.74. In the year 2007, what is the difference between the Production index(2004-2006) of Liberia and Production index(2004-2006) of Montenegro?
Offer a very short reply. 12.74. In the year 2008, what is the difference between the Production index(2004-2006) in Bulgaria and Production index(2004-2006) in Costa Rica?
Your response must be concise. 2.91. In the year 2008, what is the difference between the Production index(2004-2006) of Bulgaria and Production index(2004-2006) of Liberia?
Your answer should be very brief. -7.27. In the year 2008, what is the difference between the Production index(2004-2006) in Bulgaria and Production index(2004-2006) in Montenegro?
Ensure brevity in your answer.  14.05. In the year 2008, what is the difference between the Production index(2004-2006) in Costa Rica and Production index(2004-2006) in Liberia?
Your answer should be very brief. -10.18. In the year 2008, what is the difference between the Production index(2004-2006) in Costa Rica and Production index(2004-2006) in Montenegro?
Your answer should be very brief. 11.14. In the year 2008, what is the difference between the Production index(2004-2006) in Liberia and Production index(2004-2006) in Montenegro?
Your answer should be compact. 21.32. In the year 2009, what is the difference between the Production index(2004-2006) of Bulgaria and Production index(2004-2006) of Costa Rica?
Ensure brevity in your answer.  -8.06. In the year 2009, what is the difference between the Production index(2004-2006) in Bulgaria and Production index(2004-2006) in Liberia?
Your response must be concise. -14.32. In the year 2009, what is the difference between the Production index(2004-2006) in Bulgaria and Production index(2004-2006) in Montenegro?
Your response must be concise. 8.05. In the year 2009, what is the difference between the Production index(2004-2006) in Costa Rica and Production index(2004-2006) in Liberia?
Offer a very short reply. -6.26. In the year 2009, what is the difference between the Production index(2004-2006) of Costa Rica and Production index(2004-2006) of Montenegro?
Give a very brief answer. 16.11. In the year 2009, what is the difference between the Production index(2004-2006) of Liberia and Production index(2004-2006) of Montenegro?
Offer a very short reply. 22.37. In the year 2010, what is the difference between the Production index(2004-2006) of Bulgaria and Production index(2004-2006) of Costa Rica?
Ensure brevity in your answer.  -4.41. In the year 2010, what is the difference between the Production index(2004-2006) in Bulgaria and Production index(2004-2006) in Liberia?
Your response must be concise. -9.6. In the year 2010, what is the difference between the Production index(2004-2006) in Bulgaria and Production index(2004-2006) in Montenegro?
Give a very brief answer. 20.25. In the year 2010, what is the difference between the Production index(2004-2006) in Costa Rica and Production index(2004-2006) in Liberia?
Your response must be concise. -5.19. In the year 2010, what is the difference between the Production index(2004-2006) in Costa Rica and Production index(2004-2006) in Montenegro?
Your response must be concise. 24.66. In the year 2010, what is the difference between the Production index(2004-2006) of Liberia and Production index(2004-2006) of Montenegro?
Keep it short and to the point. 29.85. In the year 2011, what is the difference between the Production index(2004-2006) of Bulgaria and Production index(2004-2006) of Costa Rica?
Your answer should be very brief. -3.18. In the year 2011, what is the difference between the Production index(2004-2006) in Bulgaria and Production index(2004-2006) in Liberia?
Ensure brevity in your answer.  -11.39. In the year 2011, what is the difference between the Production index(2004-2006) of Bulgaria and Production index(2004-2006) of Montenegro?
Provide a succinct answer. 11.01. In the year 2011, what is the difference between the Production index(2004-2006) in Costa Rica and Production index(2004-2006) in Liberia?
Keep it short and to the point. -8.21. In the year 2011, what is the difference between the Production index(2004-2006) of Costa Rica and Production index(2004-2006) of Montenegro?
Your response must be concise. 14.19. In the year 2011, what is the difference between the Production index(2004-2006) of Liberia and Production index(2004-2006) of Montenegro?
Make the answer very short. 22.4. In the year 2012, what is the difference between the Production index(2004-2006) in Bulgaria and Production index(2004-2006) in Costa Rica?
Offer a terse response. -11.98. In the year 2012, what is the difference between the Production index(2004-2006) of Bulgaria and Production index(2004-2006) of Liberia?
Offer a terse response. -17.5. In the year 2012, what is the difference between the Production index(2004-2006) in Bulgaria and Production index(2004-2006) in Montenegro?
Your response must be concise. 17.94. In the year 2012, what is the difference between the Production index(2004-2006) in Costa Rica and Production index(2004-2006) in Liberia?
Provide a short and direct response. -5.52. In the year 2012, what is the difference between the Production index(2004-2006) of Costa Rica and Production index(2004-2006) of Montenegro?
Give a very brief answer. 29.92. In the year 2012, what is the difference between the Production index(2004-2006) of Liberia and Production index(2004-2006) of Montenegro?
Your response must be concise. 35.44. What is the ratio of the Production index(2004-2006) in Bulgaria in 1980 to that in 2006?
Give a very brief answer. 1.74. What is the ratio of the Production index(2004-2006) in Costa Rica in 1980 to that in 2006?
Offer a very short reply. 0.35. What is the ratio of the Production index(2004-2006) in Liberia in 1980 to that in 2006?
Provide a short and direct response. 0.8. What is the ratio of the Production index(2004-2006) in Montenegro in 1980 to that in 2006?
Your answer should be very brief. 1.06. What is the ratio of the Production index(2004-2006) in Bulgaria in 1980 to that in 2007?
Give a very brief answer. 2.27. What is the ratio of the Production index(2004-2006) of Costa Rica in 1980 to that in 2007?
Offer a very short reply. 0.36. What is the ratio of the Production index(2004-2006) in Liberia in 1980 to that in 2007?
Your answer should be compact. 0.73. What is the ratio of the Production index(2004-2006) in Montenegro in 1980 to that in 2007?
Your response must be concise. 1.12. What is the ratio of the Production index(2004-2006) in Bulgaria in 1980 to that in 2008?
Offer a very short reply. 1.6. What is the ratio of the Production index(2004-2006) in Costa Rica in 1980 to that in 2008?
Your answer should be compact. 0.36. What is the ratio of the Production index(2004-2006) of Liberia in 1980 to that in 2008?
Provide a short and direct response. 0.67. What is the ratio of the Production index(2004-2006) of Montenegro in 1980 to that in 2008?
Give a very brief answer. 1.11. What is the ratio of the Production index(2004-2006) in Bulgaria in 1980 to that in 2009?
Make the answer very short. 1.73. What is the ratio of the Production index(2004-2006) in Costa Rica in 1980 to that in 2009?
Keep it short and to the point. 0.35. What is the ratio of the Production index(2004-2006) of Liberia in 1980 to that in 2009?
Offer a terse response. 0.68. What is the ratio of the Production index(2004-2006) in Montenegro in 1980 to that in 2009?
Your answer should be very brief. 1.14. What is the ratio of the Production index(2004-2006) in Bulgaria in 1980 to that in 2010?
Make the answer very short. 1.58. What is the ratio of the Production index(2004-2006) of Costa Rica in 1980 to that in 2010?
Your answer should be compact. 0.34. What is the ratio of the Production index(2004-2006) in Liberia in 1980 to that in 2010?
Your answer should be very brief. 0.65. What is the ratio of the Production index(2004-2006) in Montenegro in 1980 to that in 2010?
Keep it short and to the point. 1.18. What is the ratio of the Production index(2004-2006) in Bulgaria in 1980 to that in 2011?
Offer a terse response. 1.54. What is the ratio of the Production index(2004-2006) in Costa Rica in 1980 to that in 2011?
Provide a succinct answer. 0.33. What is the ratio of the Production index(2004-2006) of Liberia in 1980 to that in 2011?
Make the answer very short. 0.62. What is the ratio of the Production index(2004-2006) of Montenegro in 1980 to that in 2011?
Your answer should be compact. 1.03. What is the ratio of the Production index(2004-2006) in Bulgaria in 1980 to that in 2012?
Your answer should be very brief. 1.62. What is the ratio of the Production index(2004-2006) of Costa Rica in 1980 to that in 2012?
Make the answer very short. 0.32. What is the ratio of the Production index(2004-2006) in Liberia in 1980 to that in 2012?
Keep it short and to the point. 0.62. What is the ratio of the Production index(2004-2006) of Montenegro in 1980 to that in 2012?
Keep it short and to the point. 1.18. What is the ratio of the Production index(2004-2006) of Bulgaria in 2006 to that in 2007?
Your answer should be very brief. 1.31. What is the ratio of the Production index(2004-2006) in Costa Rica in 2006 to that in 2007?
Make the answer very short. 1.02. What is the ratio of the Production index(2004-2006) of Liberia in 2006 to that in 2007?
Make the answer very short. 0.91. What is the ratio of the Production index(2004-2006) in Montenegro in 2006 to that in 2007?
Give a very brief answer. 1.06. What is the ratio of the Production index(2004-2006) in Bulgaria in 2006 to that in 2008?
Provide a short and direct response. 0.92. What is the ratio of the Production index(2004-2006) of Costa Rica in 2006 to that in 2008?
Offer a terse response. 1.04. What is the ratio of the Production index(2004-2006) of Liberia in 2006 to that in 2008?
Your answer should be very brief. 0.83. What is the ratio of the Production index(2004-2006) of Montenegro in 2006 to that in 2008?
Keep it short and to the point. 1.05. What is the ratio of the Production index(2004-2006) of Costa Rica in 2006 to that in 2009?
Provide a succinct answer. 1.01. What is the ratio of the Production index(2004-2006) in Liberia in 2006 to that in 2009?
Offer a very short reply. 0.84. What is the ratio of the Production index(2004-2006) in Montenegro in 2006 to that in 2009?
Provide a succinct answer. 1.08. What is the ratio of the Production index(2004-2006) in Bulgaria in 2006 to that in 2010?
Keep it short and to the point. 0.91. What is the ratio of the Production index(2004-2006) of Costa Rica in 2006 to that in 2010?
Ensure brevity in your answer.  0.96. What is the ratio of the Production index(2004-2006) in Liberia in 2006 to that in 2010?
Your answer should be compact. 0.81. What is the ratio of the Production index(2004-2006) in Montenegro in 2006 to that in 2010?
Make the answer very short. 1.11. What is the ratio of the Production index(2004-2006) of Bulgaria in 2006 to that in 2011?
Make the answer very short. 0.88. What is the ratio of the Production index(2004-2006) in Costa Rica in 2006 to that in 2011?
Offer a very short reply. 0.95. What is the ratio of the Production index(2004-2006) of Liberia in 2006 to that in 2011?
Your answer should be very brief. 0.78. What is the ratio of the Production index(2004-2006) in Montenegro in 2006 to that in 2011?
Provide a short and direct response. 0.97. What is the ratio of the Production index(2004-2006) of Bulgaria in 2006 to that in 2012?
Your response must be concise. 0.93. What is the ratio of the Production index(2004-2006) in Costa Rica in 2006 to that in 2012?
Your answer should be compact. 0.92. What is the ratio of the Production index(2004-2006) in Liberia in 2006 to that in 2012?
Offer a terse response. 0.77. What is the ratio of the Production index(2004-2006) in Montenegro in 2006 to that in 2012?
Give a very brief answer. 1.11. What is the ratio of the Production index(2004-2006) of Bulgaria in 2007 to that in 2008?
Keep it short and to the point. 0.7. What is the ratio of the Production index(2004-2006) in Costa Rica in 2007 to that in 2008?
Offer a very short reply. 1.02. What is the ratio of the Production index(2004-2006) of Liberia in 2007 to that in 2008?
Make the answer very short. 0.92. What is the ratio of the Production index(2004-2006) in Montenegro in 2007 to that in 2008?
Keep it short and to the point. 0.99. What is the ratio of the Production index(2004-2006) in Bulgaria in 2007 to that in 2009?
Your answer should be very brief. 0.76. What is the ratio of the Production index(2004-2006) in Liberia in 2007 to that in 2009?
Provide a short and direct response. 0.93. What is the ratio of the Production index(2004-2006) of Montenegro in 2007 to that in 2009?
Ensure brevity in your answer.  1.01. What is the ratio of the Production index(2004-2006) in Bulgaria in 2007 to that in 2010?
Keep it short and to the point. 0.7. What is the ratio of the Production index(2004-2006) of Costa Rica in 2007 to that in 2010?
Provide a short and direct response. 0.94. What is the ratio of the Production index(2004-2006) in Liberia in 2007 to that in 2010?
Offer a terse response. 0.89. What is the ratio of the Production index(2004-2006) of Montenegro in 2007 to that in 2010?
Your answer should be very brief. 1.05. What is the ratio of the Production index(2004-2006) of Bulgaria in 2007 to that in 2011?
Give a very brief answer. 0.68. What is the ratio of the Production index(2004-2006) of Costa Rica in 2007 to that in 2011?
Provide a short and direct response. 0.92. What is the ratio of the Production index(2004-2006) of Liberia in 2007 to that in 2011?
Ensure brevity in your answer.  0.86. What is the ratio of the Production index(2004-2006) of Montenegro in 2007 to that in 2011?
Offer a terse response. 0.92. What is the ratio of the Production index(2004-2006) of Bulgaria in 2007 to that in 2012?
Provide a short and direct response. 0.71. What is the ratio of the Production index(2004-2006) of Costa Rica in 2007 to that in 2012?
Offer a terse response. 0.9. What is the ratio of the Production index(2004-2006) of Liberia in 2007 to that in 2012?
Provide a succinct answer. 0.85. What is the ratio of the Production index(2004-2006) in Montenegro in 2007 to that in 2012?
Offer a terse response. 1.05. What is the ratio of the Production index(2004-2006) in Bulgaria in 2008 to that in 2009?
Your answer should be very brief. 1.08. What is the ratio of the Production index(2004-2006) of Costa Rica in 2008 to that in 2009?
Make the answer very short. 0.98. What is the ratio of the Production index(2004-2006) of Montenegro in 2008 to that in 2009?
Provide a short and direct response. 1.02. What is the ratio of the Production index(2004-2006) of Bulgaria in 2008 to that in 2010?
Provide a succinct answer. 0.99. What is the ratio of the Production index(2004-2006) of Costa Rica in 2008 to that in 2010?
Make the answer very short. 0.93. What is the ratio of the Production index(2004-2006) of Liberia in 2008 to that in 2010?
Make the answer very short. 0.97. What is the ratio of the Production index(2004-2006) of Montenegro in 2008 to that in 2010?
Provide a succinct answer. 1.06. What is the ratio of the Production index(2004-2006) in Bulgaria in 2008 to that in 2011?
Ensure brevity in your answer.  0.96. What is the ratio of the Production index(2004-2006) in Costa Rica in 2008 to that in 2011?
Make the answer very short. 0.91. What is the ratio of the Production index(2004-2006) in Liberia in 2008 to that in 2011?
Offer a terse response. 0.93. What is the ratio of the Production index(2004-2006) of Montenegro in 2008 to that in 2011?
Offer a very short reply. 0.93. What is the ratio of the Production index(2004-2006) of Bulgaria in 2008 to that in 2012?
Make the answer very short. 1.01. What is the ratio of the Production index(2004-2006) in Costa Rica in 2008 to that in 2012?
Give a very brief answer. 0.89. What is the ratio of the Production index(2004-2006) in Liberia in 2008 to that in 2012?
Ensure brevity in your answer.  0.93. What is the ratio of the Production index(2004-2006) of Montenegro in 2008 to that in 2012?
Provide a short and direct response. 1.06. What is the ratio of the Production index(2004-2006) of Bulgaria in 2009 to that in 2010?
Provide a succinct answer. 0.91. What is the ratio of the Production index(2004-2006) of Costa Rica in 2009 to that in 2010?
Offer a terse response. 0.95. What is the ratio of the Production index(2004-2006) in Liberia in 2009 to that in 2010?
Provide a succinct answer. 0.96. What is the ratio of the Production index(2004-2006) in Montenegro in 2009 to that in 2010?
Your answer should be compact. 1.03. What is the ratio of the Production index(2004-2006) in Bulgaria in 2009 to that in 2011?
Offer a very short reply. 0.89. What is the ratio of the Production index(2004-2006) in Costa Rica in 2009 to that in 2011?
Offer a terse response. 0.93. What is the ratio of the Production index(2004-2006) of Liberia in 2009 to that in 2011?
Keep it short and to the point. 0.92. What is the ratio of the Production index(2004-2006) in Montenegro in 2009 to that in 2011?
Offer a terse response. 0.91. What is the ratio of the Production index(2004-2006) of Bulgaria in 2009 to that in 2012?
Make the answer very short. 0.94. What is the ratio of the Production index(2004-2006) in Costa Rica in 2009 to that in 2012?
Make the answer very short. 0.91. What is the ratio of the Production index(2004-2006) of Liberia in 2009 to that in 2012?
Your answer should be very brief. 0.92. What is the ratio of the Production index(2004-2006) of Montenegro in 2009 to that in 2012?
Provide a short and direct response. 1.03. What is the ratio of the Production index(2004-2006) in Bulgaria in 2010 to that in 2011?
Your answer should be very brief. 0.97. What is the ratio of the Production index(2004-2006) of Costa Rica in 2010 to that in 2011?
Provide a short and direct response. 0.98. What is the ratio of the Production index(2004-2006) of Liberia in 2010 to that in 2011?
Make the answer very short. 0.96. What is the ratio of the Production index(2004-2006) of Montenegro in 2010 to that in 2011?
Offer a very short reply. 0.88. What is the ratio of the Production index(2004-2006) in Bulgaria in 2010 to that in 2012?
Your response must be concise. 1.02. What is the ratio of the Production index(2004-2006) of Costa Rica in 2010 to that in 2012?
Make the answer very short. 0.96. What is the ratio of the Production index(2004-2006) in Liberia in 2010 to that in 2012?
Ensure brevity in your answer.  0.96. What is the ratio of the Production index(2004-2006) of Montenegro in 2010 to that in 2012?
Offer a very short reply. 1. What is the ratio of the Production index(2004-2006) of Bulgaria in 2011 to that in 2012?
Your response must be concise. 1.05. What is the ratio of the Production index(2004-2006) in Costa Rica in 2011 to that in 2012?
Provide a short and direct response. 0.97. What is the ratio of the Production index(2004-2006) in Montenegro in 2011 to that in 2012?
Your response must be concise. 1.14. What is the difference between the highest and the second highest Production index(2004-2006) of Bulgaria?
Offer a very short reply. 61.02. What is the difference between the highest and the second highest Production index(2004-2006) in Costa Rica?
Provide a succinct answer. 3.02. What is the difference between the highest and the second highest Production index(2004-2006) in Liberia?
Give a very brief answer. 0.33. What is the difference between the highest and the second highest Production index(2004-2006) of Montenegro?
Make the answer very short. 3.31. What is the difference between the highest and the lowest Production index(2004-2006) of Bulgaria?
Make the answer very short. 97.8. What is the difference between the highest and the lowest Production index(2004-2006) in Costa Rica?
Ensure brevity in your answer.  81.48. What is the difference between the highest and the lowest Production index(2004-2006) in Liberia?
Give a very brief answer. 47.49. What is the difference between the highest and the lowest Production index(2004-2006) in Montenegro?
Offer a terse response. 16.02. 